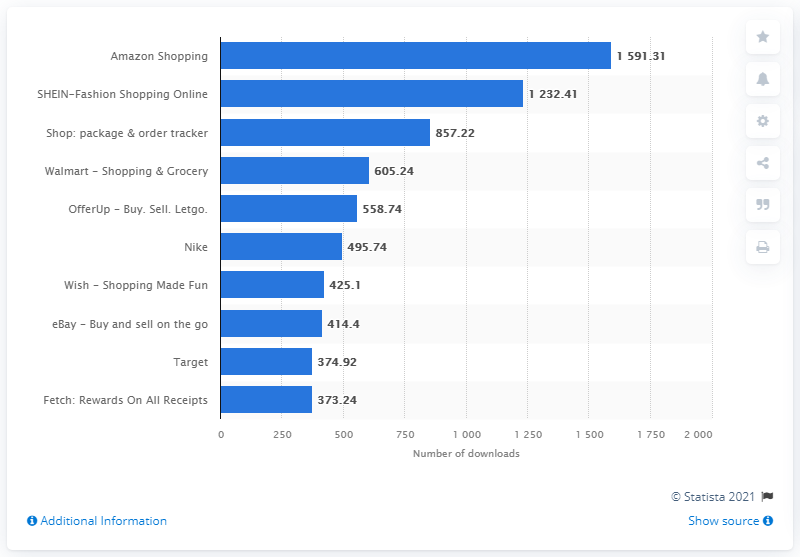Draw attention to some important aspects in this diagram. Amazon Shopping was the most downloaded shopping app for iPhone in the US in April 2021. 